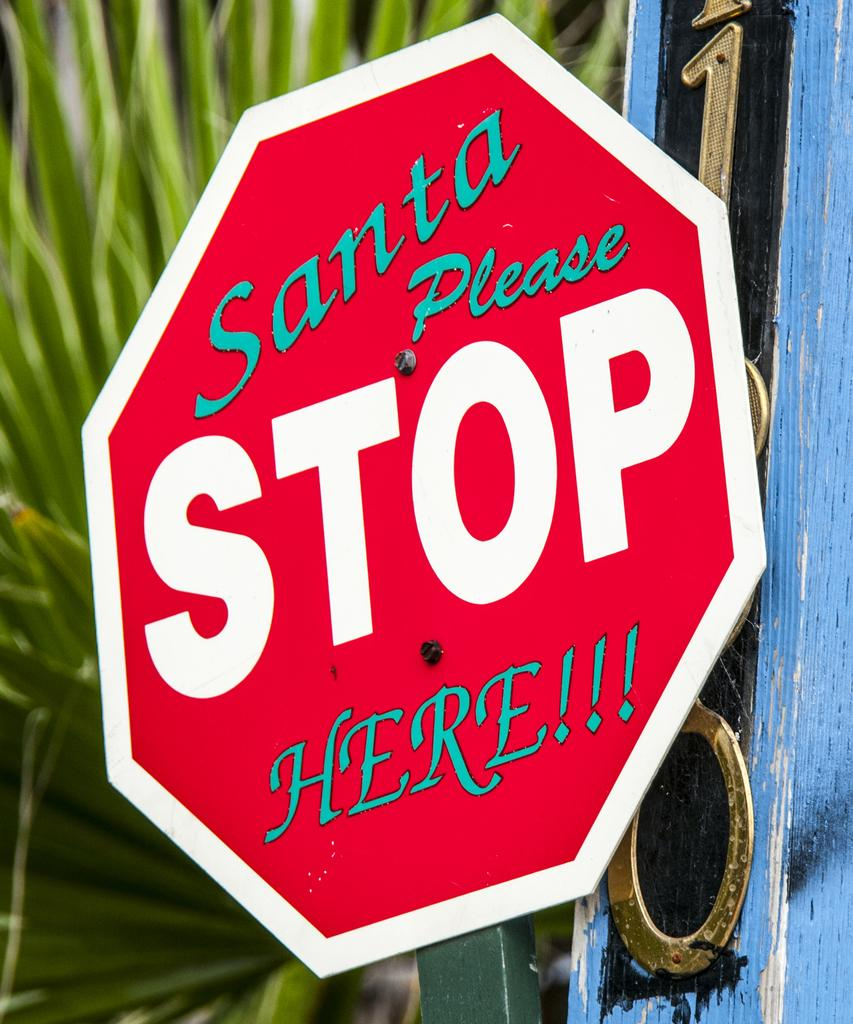<image>
Share a concise interpretation of the image provided. A closeup on a sign that reads, "Santa please stop here". 